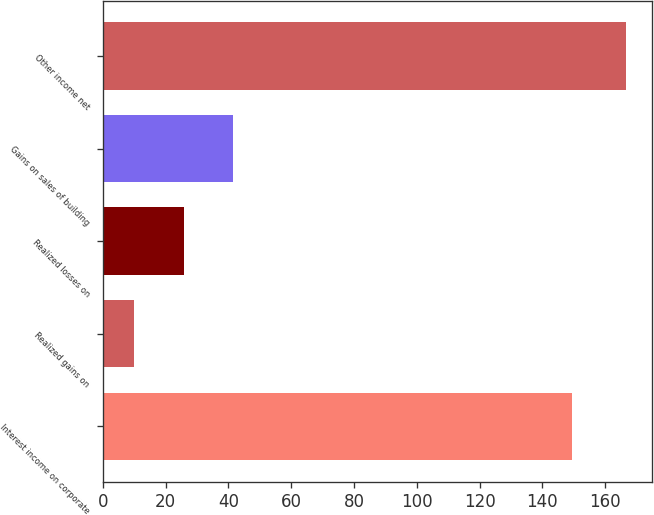Convert chart to OTSL. <chart><loc_0><loc_0><loc_500><loc_500><bar_chart><fcel>Interest income on corporate<fcel>Realized gains on<fcel>Realized losses on<fcel>Gains on sales of building<fcel>Other income net<nl><fcel>149.5<fcel>10.1<fcel>25.74<fcel>41.38<fcel>166.5<nl></chart> 